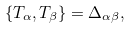Convert formula to latex. <formula><loc_0><loc_0><loc_500><loc_500>\{ T _ { \alpha } , T _ { \beta } \} = \Delta _ { \alpha \beta } ,</formula> 